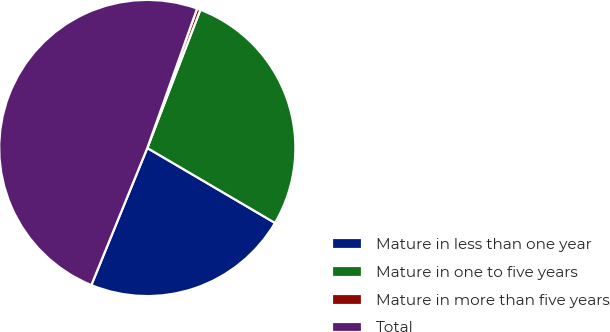Convert chart. <chart><loc_0><loc_0><loc_500><loc_500><pie_chart><fcel>Mature in less than one year<fcel>Mature in one to five years<fcel>Mature in more than five years<fcel>Total<nl><fcel>22.72%<fcel>27.61%<fcel>0.38%<fcel>49.29%<nl></chart> 